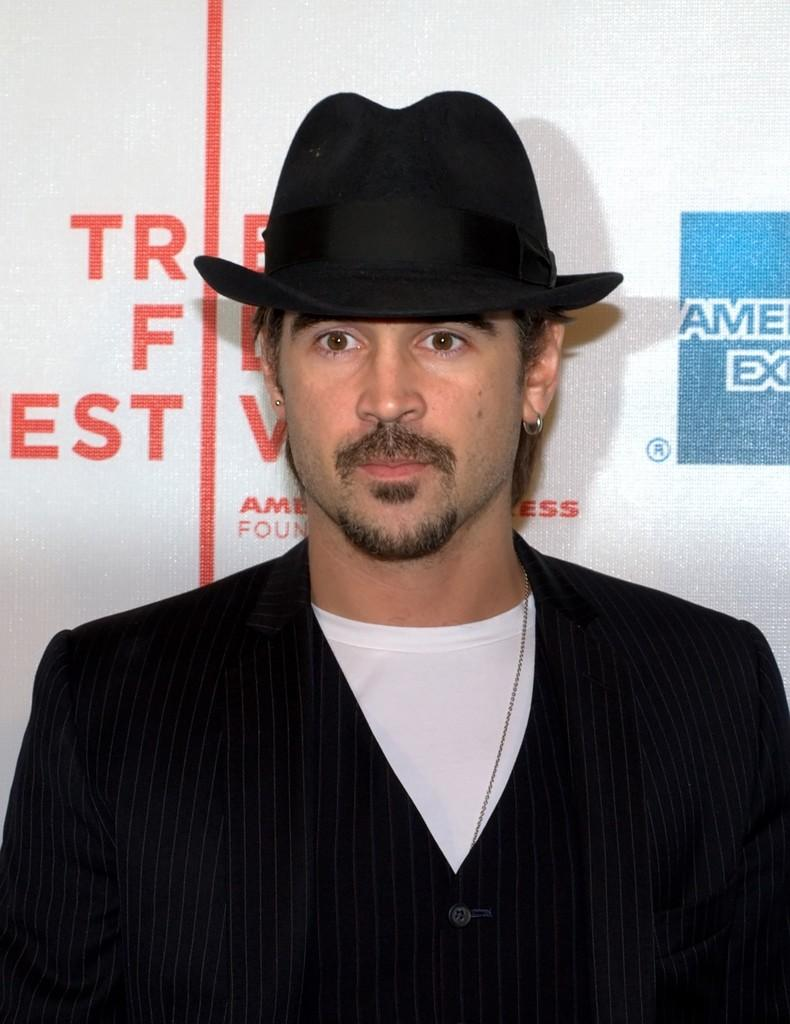What is the main subject in the middle of the image? There is a man in the middle of the image. What type of clothing is the man wearing? The man is wearing a coat, a T-shirt, and a hat. What can be seen in the background of the image? There is a banner in the background of the image. What is written on the banner? The banner has text on it. Can you see any ants crawling on the man's coat in the image? There are no ants visible in the image. Why is the man crying in the image? The man is not crying in the image; there is no indication of any emotional state. 